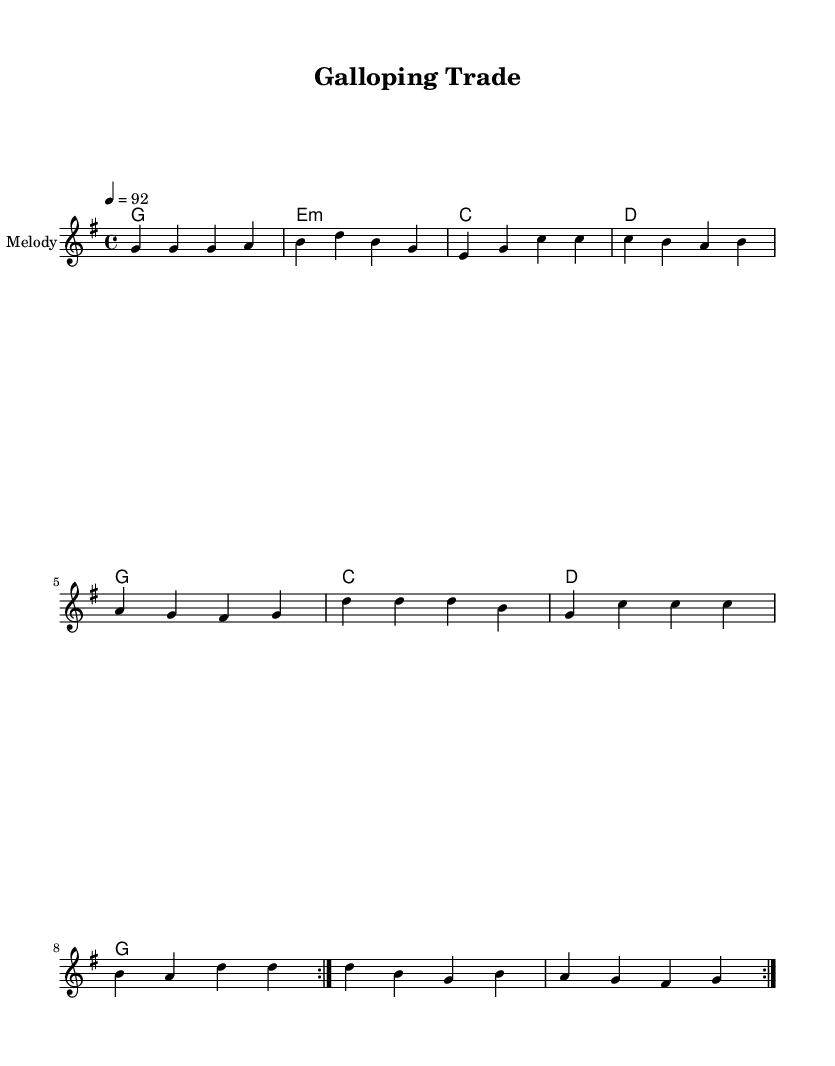What is the key signature of this music? The key signature can be found at the beginning of the staff, indicated by the sharps or flats present. In this case, there are no sharps or flats shown, which designates the key as G major.
Answer: G major What is the time signature of this music? The time signature is located at the beginning of the piece, next to the key signature. Here, it is indicated as 4/4, which means there are four beats in each measure and the quarter note gets one beat.
Answer: 4/4 What is the tempo marking for this piece? The tempo marking is specified by a number that indicates beats per minute. In this score, it is mentioned as '4 = 92,' which means there are 92 beats in one minute, correspondingly making the tempo moderate.
Answer: 92 How many measures are repeated in the main melody? The repeat section is indicated by 'repeat volta 2,' which signifies that the preceding measures will be played twice before moving on. By counting the measures in the repeated section, we find the total is eight measures in the melody.
Answer: 8 Which chord is used after the G chord in the first repetition? By looking at the chord progression below the melody, after the G chord (first measure), the next chord noted is E minor. The sequential order indicates it follows the G chord directly.
Answer: E minor What is the lyrical theme present in this music? The lyrics mention 'galloping trade' and focus on global commerce and equestrian equipment, indicating themes of international trade and the unity of nations through equestrian connections. Thus, the thematic exploration revolves around commerce and collaboration.
Answer: Global trade 